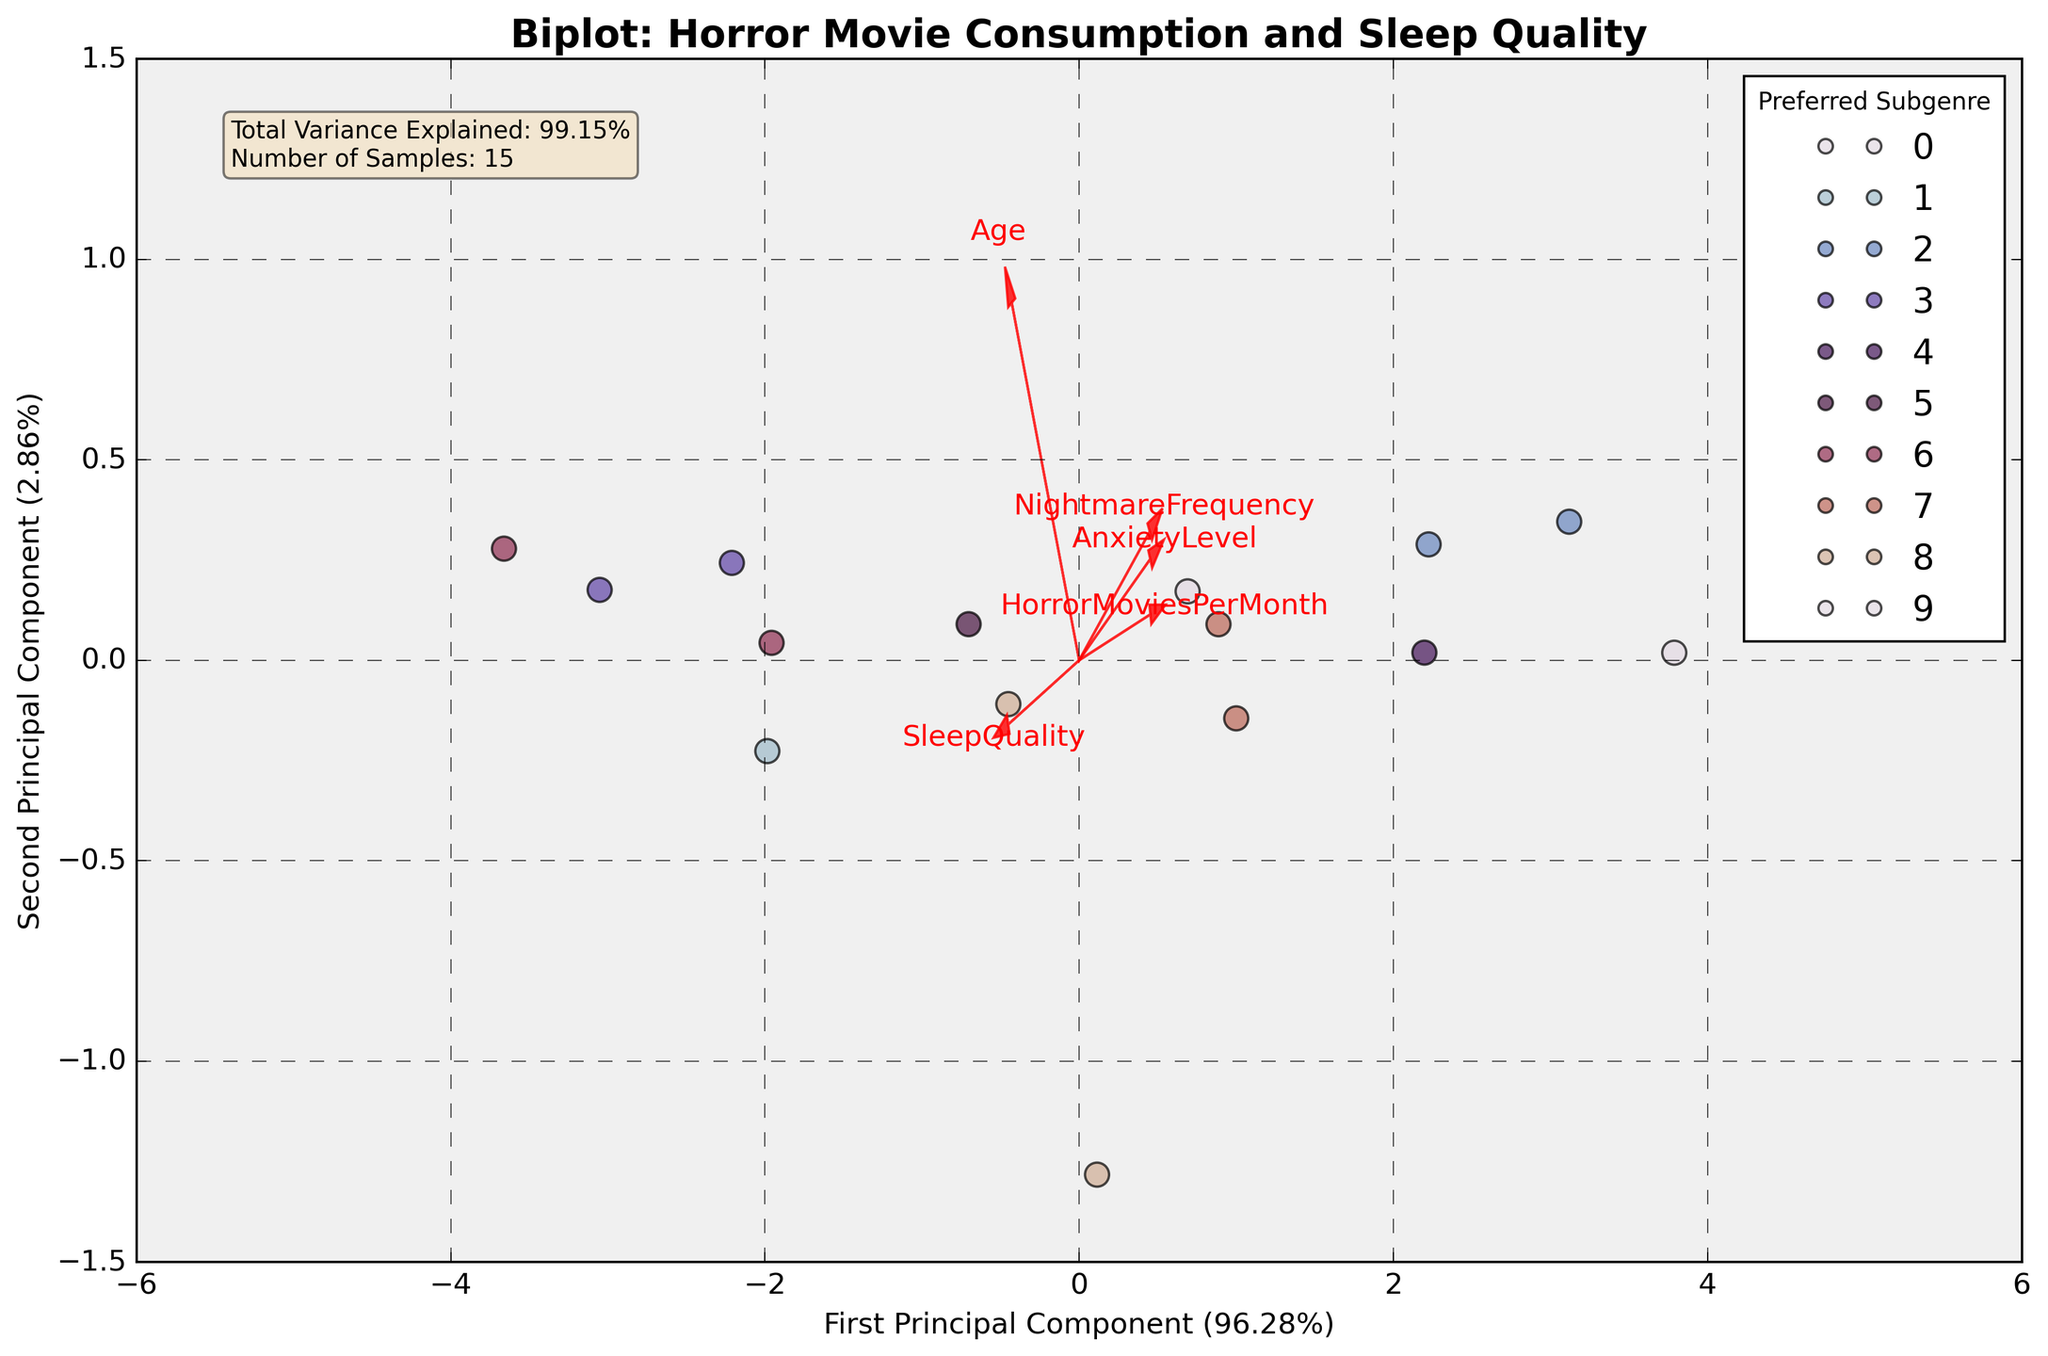What's the title of the figure? The title of the figure is usually displayed at the top of the chart. By reading it, we can learn what the figure is about.
Answer: Biplot: Horror Movie Consumption and Sleep Quality What do the arrows in the biplot represent? The arrows indicate the direction and magnitude of the original features in the principal component space. They show how each feature contributes to the principal components.
Answer: Features How many different preferred subgenres are shown in the legend? The number of categories in the legend corresponds to the number of different colors or labels used to represent preferred subgenres in the plot.
Answer: Seven Which feature has the longest arrow in the biplot? The length of the arrow represents the variance each feature explains in the PCA. The longest arrow is the one extending the farthest from the origin.
Answer: Age Do younger age groups generally have higher horror movie consumption rates? By observing the biplot, we can see if data points representing younger ages are located in regions corresponding to higher horror movie consumption.
Answer: Yes Which principal component explains more variance? The axis labels provide the percentage of the variance explained by each principal component. The one with the higher percentage explains more variance.
Answer: First Principal Component How do 'SleepQuality' and 'AnxietyLevel' compare in terms of their contribution to the second principal component? The direction and length of the arrows in the PCA biplot can indicate how much 'SleepQuality' and 'AnxietyLevel' contribute to the second principal component.
Answer: Similar contribution What is the relationship between 'NightmareFrequency' and 'AnxietyLevel'? By observing the direction of the arrows for both 'NightmareFrequency' and 'AnxietyLevel', we can infer if they have a positive or negative correlation based on their alignment.
Answer: Positive correlation Are data points with high 'HorrorMoviesPerMonth' also associated with high 'AnxietyLevel'? Points with high values for both features would likely be clustered in the same area or along similar directions as indicated by feature vectors.
Answer: Yes 